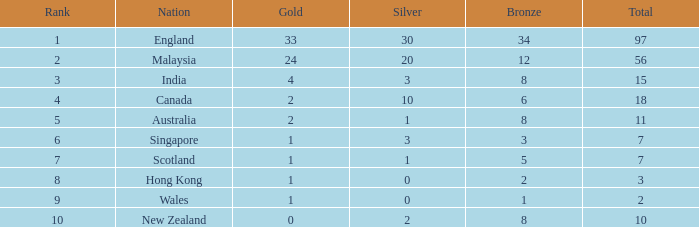What is the quantity of bronze that scotland, having fewer than 7 overall medals, possesses? None. 